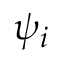<formula> <loc_0><loc_0><loc_500><loc_500>\psi _ { i }</formula> 